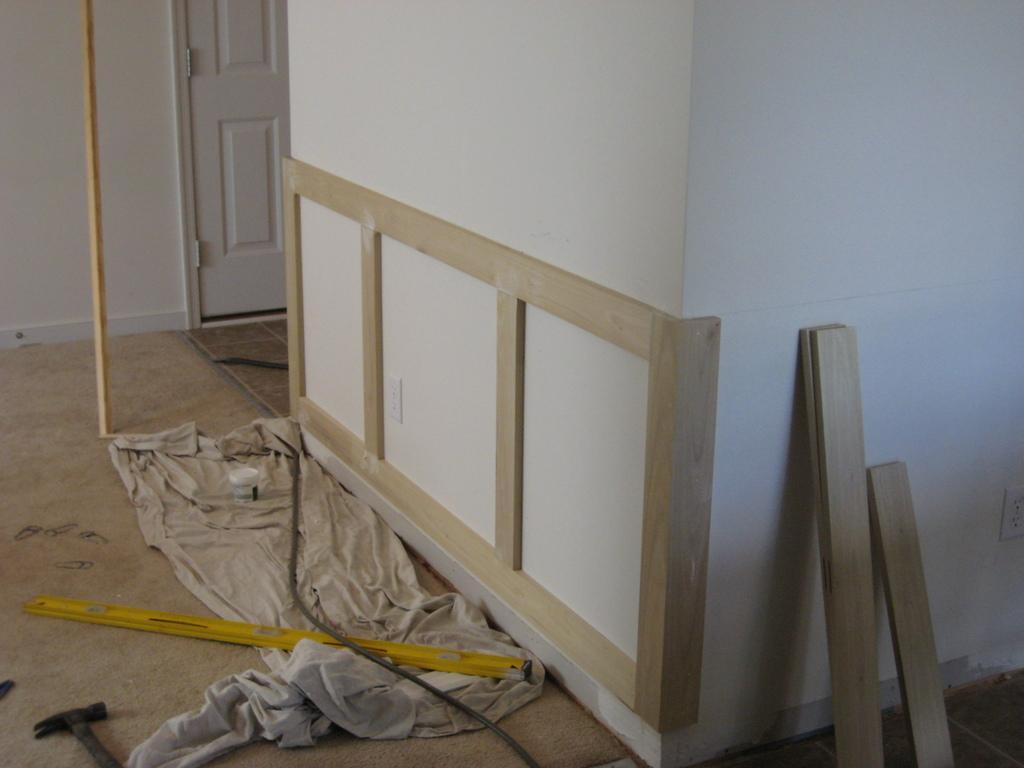Describe this image in one or two sentences. In the image there are some tools and cloth on the floor with wooden sheets on the right side in the front of the wall, on the left side there is a door to the room. 